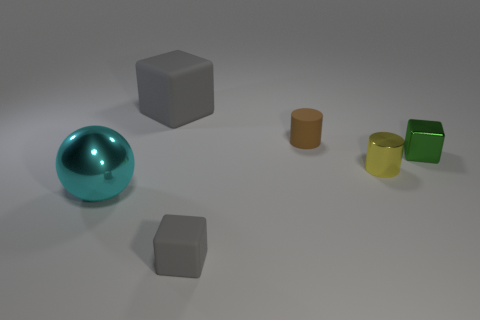Are there any big green blocks?
Provide a short and direct response. No. Does the big rubber block have the same color as the tiny matte block?
Provide a succinct answer. Yes. What number of tiny objects are either spheres or purple balls?
Your answer should be compact. 0. Is there any other thing that is the same color as the large matte thing?
Make the answer very short. Yes. The small brown thing that is made of the same material as the large gray object is what shape?
Give a very brief answer. Cylinder. How big is the gray cube that is behind the brown object?
Offer a very short reply. Large. The small brown thing is what shape?
Offer a very short reply. Cylinder. There is a matte block behind the metallic block; is it the same size as the gray rubber object that is in front of the cyan metallic ball?
Give a very brief answer. No. There is a yellow metal thing that is to the right of the matte thing that is in front of the small cube behind the small gray block; what size is it?
Make the answer very short. Small. The big thing on the left side of the big object that is on the right side of the big object in front of the small green block is what shape?
Your answer should be very brief. Sphere. 